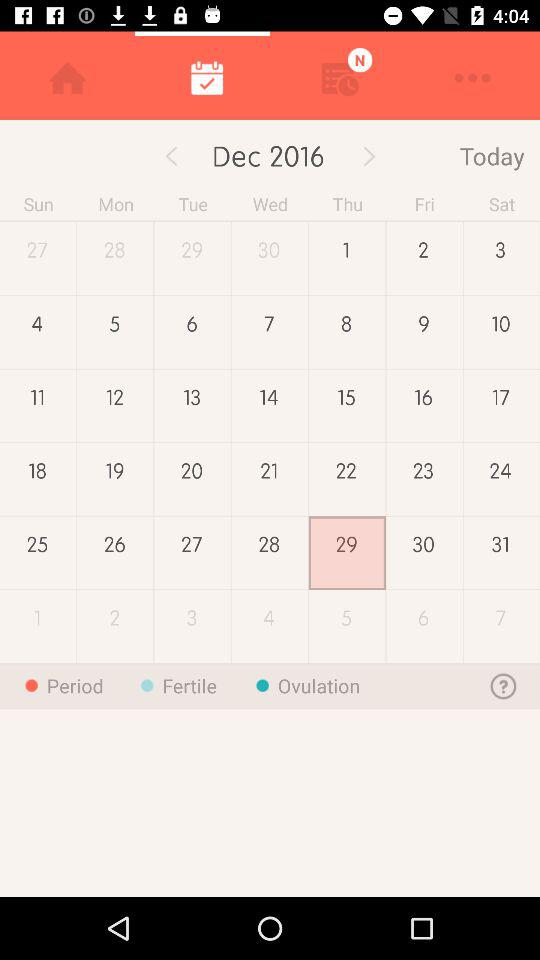What is the name of the application?
When the provided information is insufficient, respond with <no answer>. <no answer> 